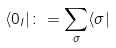<formula> <loc_0><loc_0><loc_500><loc_500>\langle 0 _ { l } | \colon = \sum _ { \sigma } \langle \sigma |</formula> 